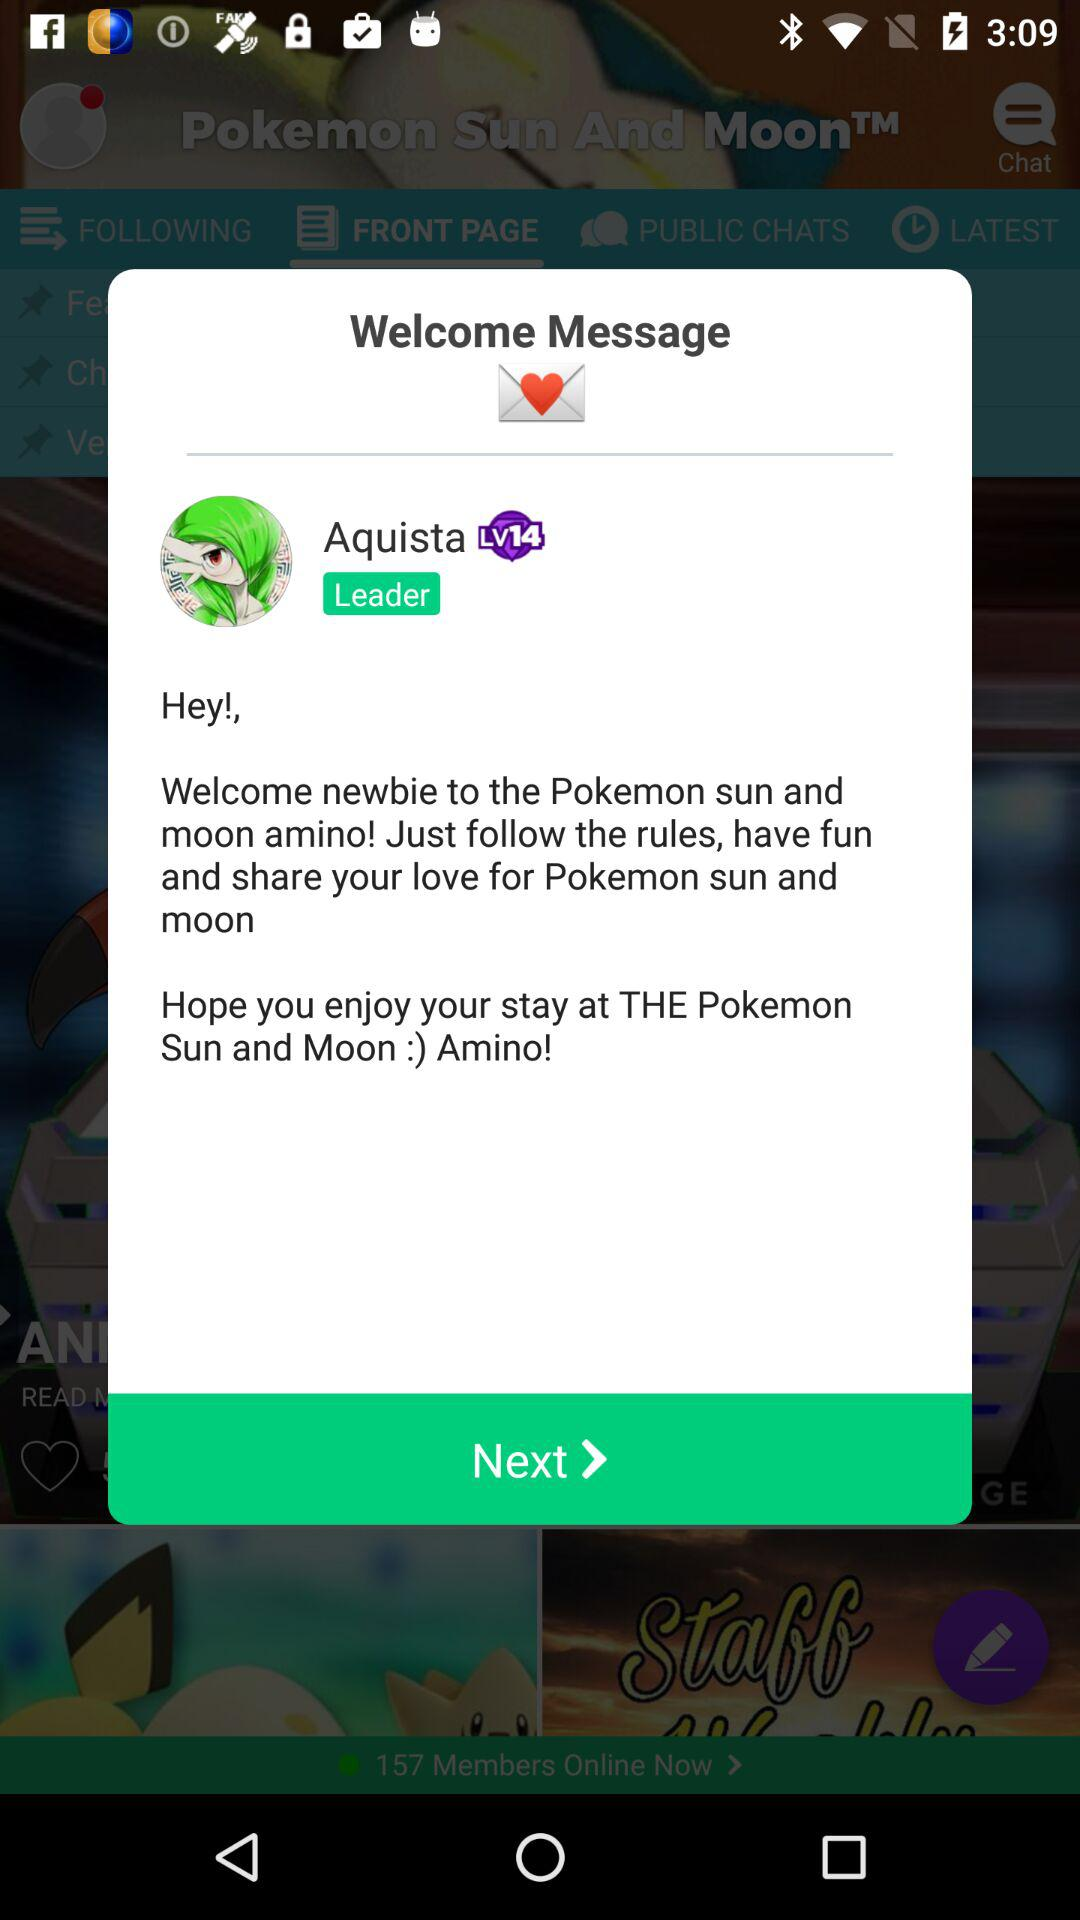What is the name of the leader? The name of the leader is Aquista. 